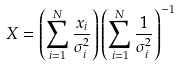Convert formula to latex. <formula><loc_0><loc_0><loc_500><loc_500>X = \left ( \sum _ { i = 1 } ^ { N } \frac { x _ { i } } { \sigma _ { i } ^ { 2 } } \right ) \left ( \sum _ { i = 1 } ^ { N } \frac { 1 } { \sigma _ { i } ^ { 2 } } \right ) ^ { - 1 }</formula> 